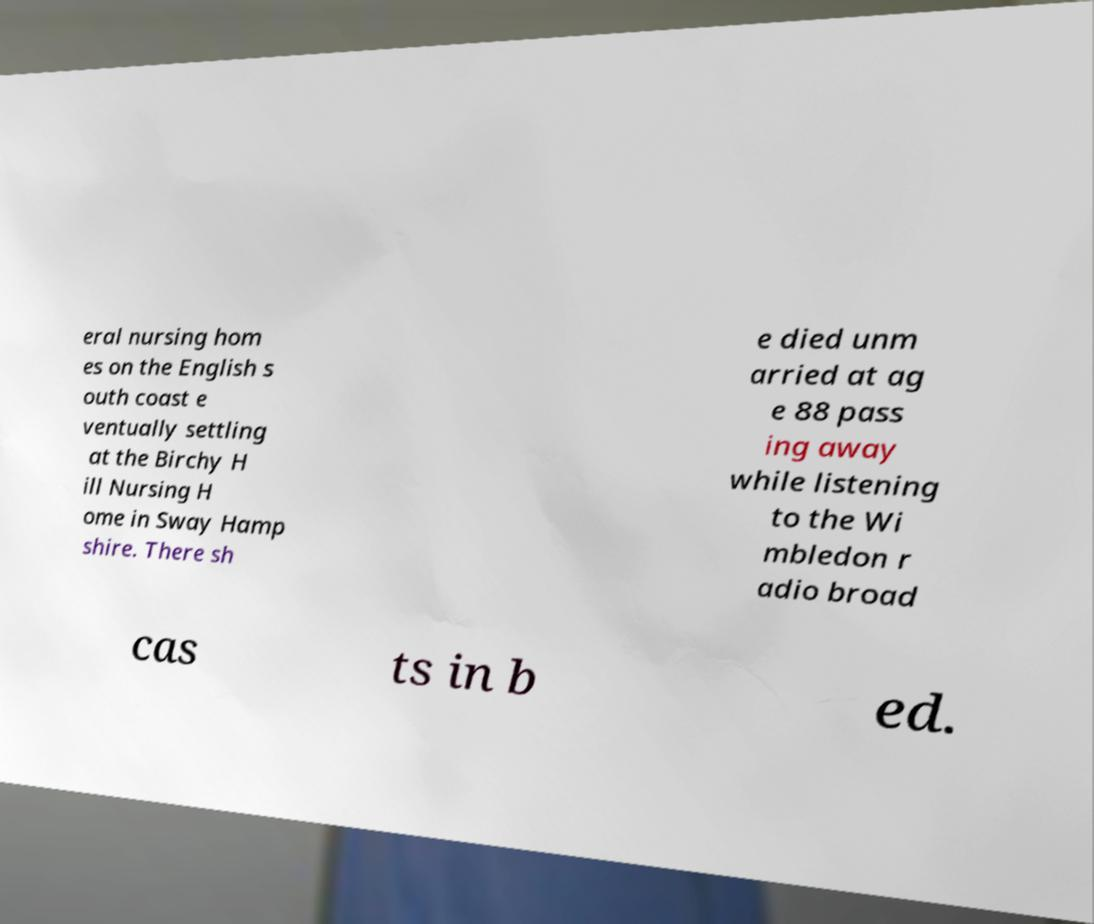I need the written content from this picture converted into text. Can you do that? eral nursing hom es on the English s outh coast e ventually settling at the Birchy H ill Nursing H ome in Sway Hamp shire. There sh e died unm arried at ag e 88 pass ing away while listening to the Wi mbledon r adio broad cas ts in b ed. 